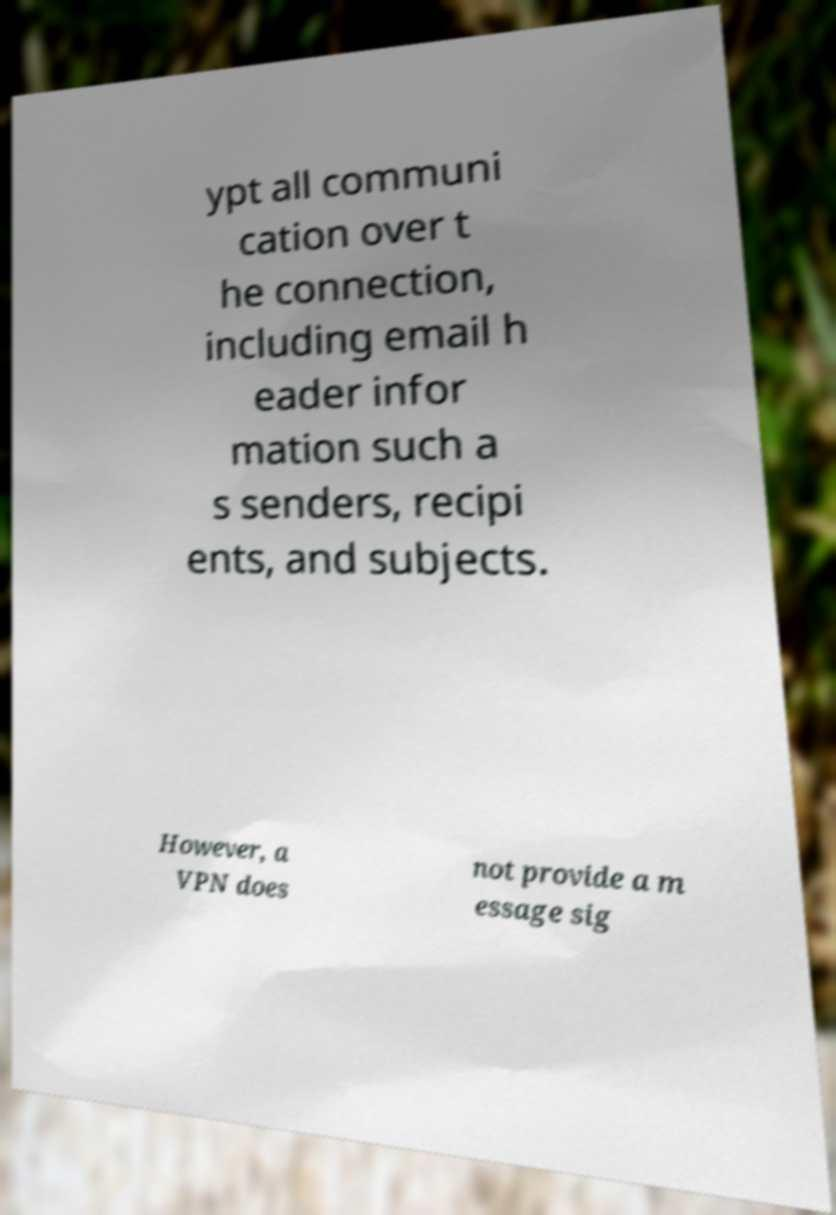Can you accurately transcribe the text from the provided image for me? ypt all communi cation over t he connection, including email h eader infor mation such a s senders, recipi ents, and subjects. However, a VPN does not provide a m essage sig 